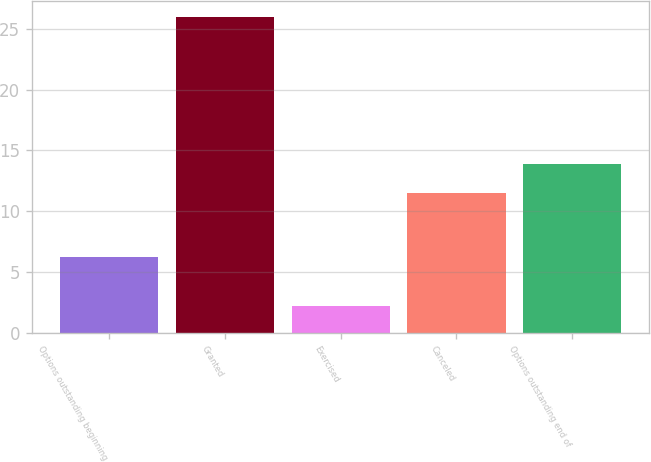Convert chart to OTSL. <chart><loc_0><loc_0><loc_500><loc_500><bar_chart><fcel>Options outstanding beginning<fcel>Granted<fcel>Exercised<fcel>Canceled<fcel>Options outstanding end of<nl><fcel>6.25<fcel>26<fcel>2.25<fcel>11.54<fcel>13.91<nl></chart> 